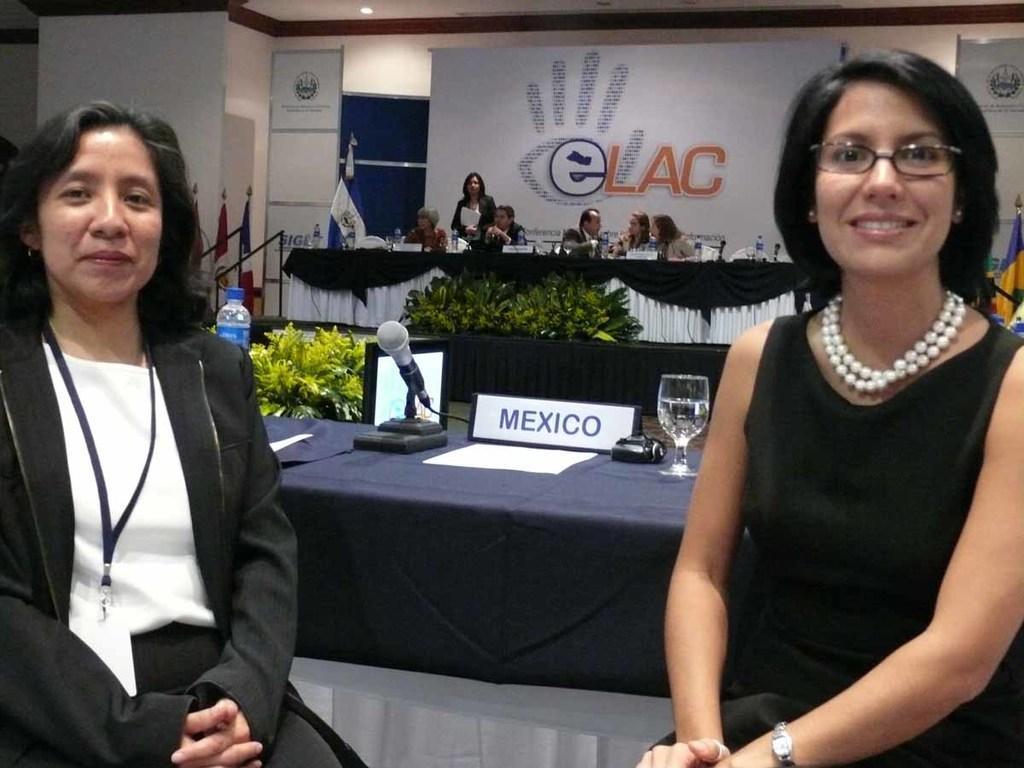Describe this image in one or two sentences. This image consists of two women. In the background, we can see few persons. In the middle, there is a table on which we can see a mic and a glass along with a name board. In the background, there is a banner and a wall. On the left, there are flags. 